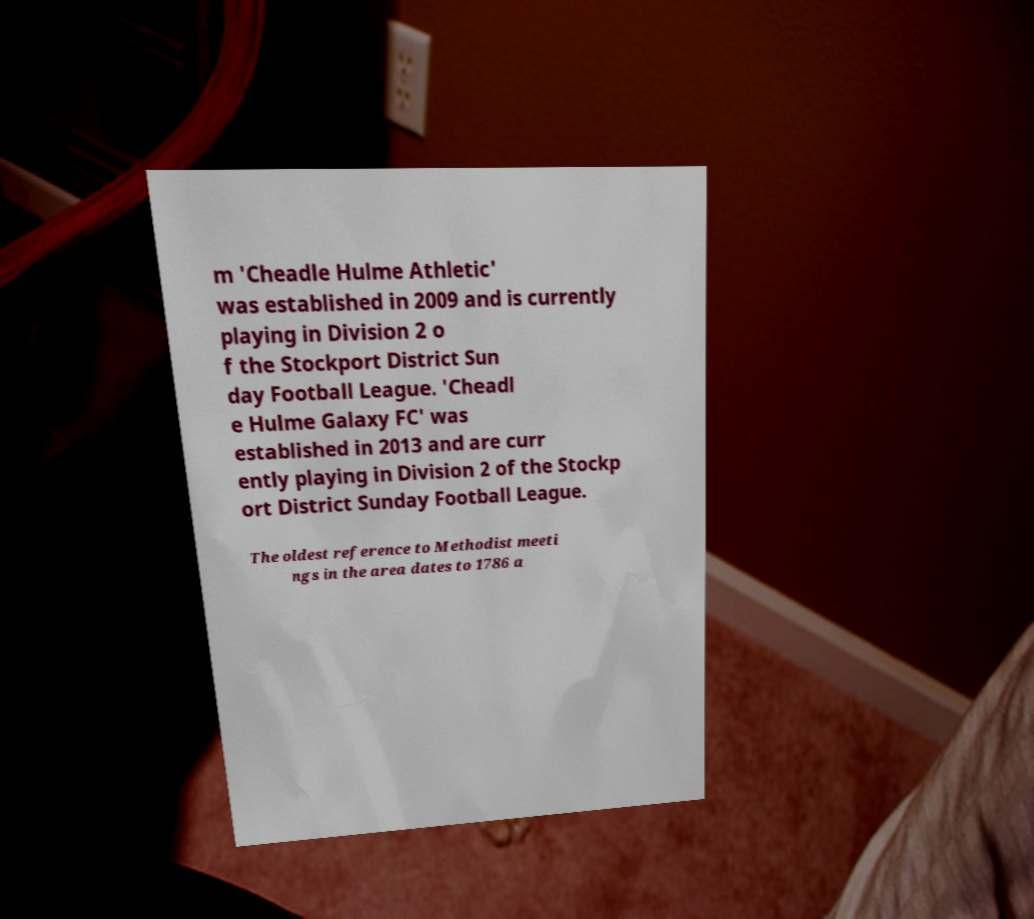Can you accurately transcribe the text from the provided image for me? m 'Cheadle Hulme Athletic' was established in 2009 and is currently playing in Division 2 o f the Stockport District Sun day Football League. 'Cheadl e Hulme Galaxy FC' was established in 2013 and are curr ently playing in Division 2 of the Stockp ort District Sunday Football League. The oldest reference to Methodist meeti ngs in the area dates to 1786 a 